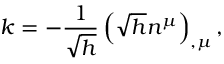Convert formula to latex. <formula><loc_0><loc_0><loc_500><loc_500>k = - \frac { 1 } \sqrt { h } } \left ( \sqrt { h } n ^ { \mu } \right ) _ { , \mu } ,</formula> 